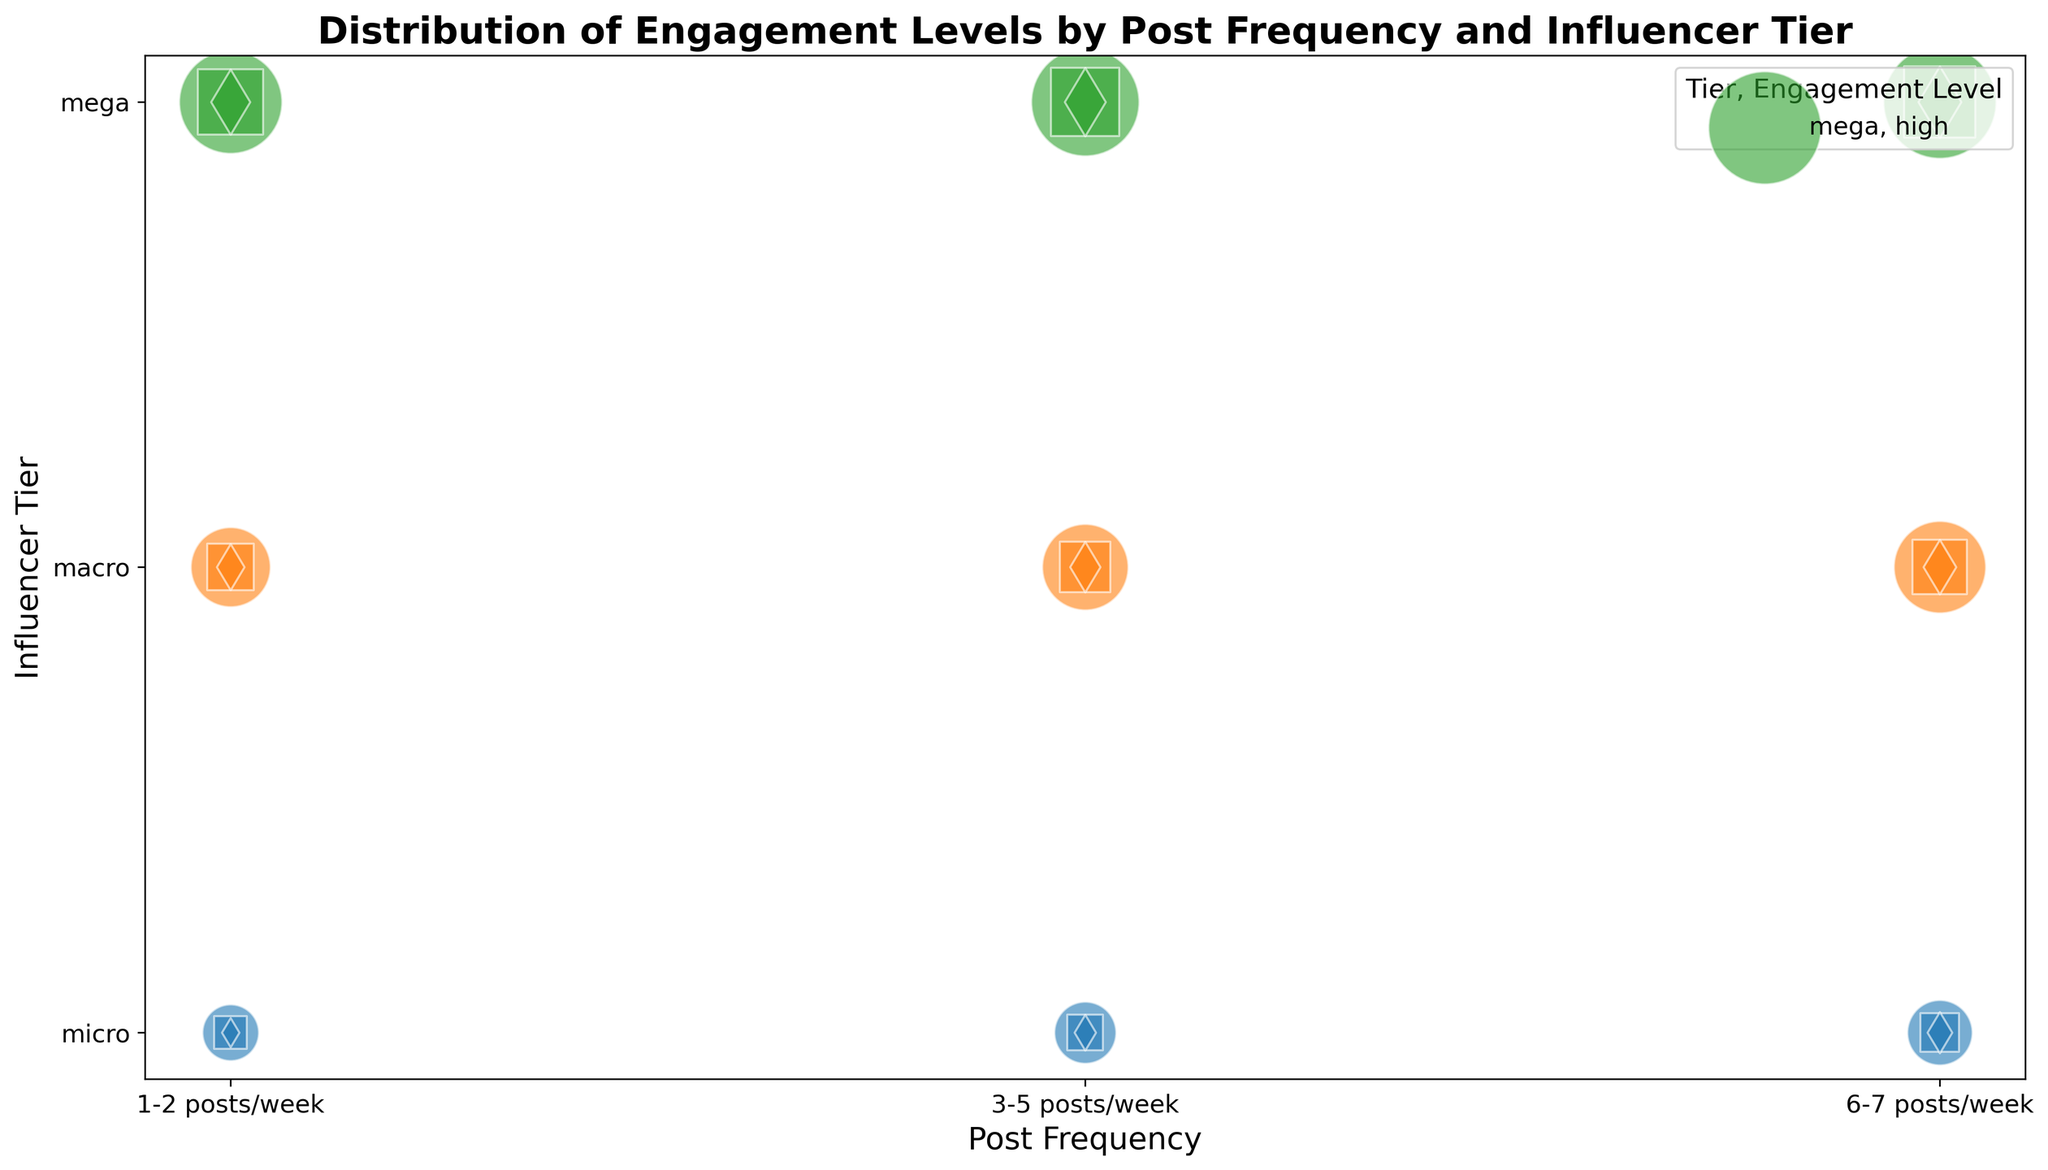What is the tier with the highest engagement count for 6-7 posts/week? For 6-7 posts/week, the bubble sizes represent engagement counts. The largest bubble size in this category appears in the "mega" tier for high engagement level.
Answer: mega Which engagement level is most common among micro influencers with 3-5 posts/week? The bubble sizes indicate the engagement counts for each level. The high engagement level has the largest bubble size among micro influencers with 3-5 posts/week.
Answer: high Compare the engagement counts for high engagement levels between macro influencers with 1-2 posts/week and micro influencers with the same frequency. Which tier has higher engagement? By comparing the bubble sizes for high engagement levels: macro influencers have a larger bubble size than micro influencers for 1-2 posts/week, indicating higher engagement.
Answer: macro What's the average engagement count for medium engagement levels across all tiers for 6-7 posts/week? Summing up the engagement counts for medium engagement levels at 6-7 posts/week: 70 (micro) + 140 (macro) + 240 (mega) = 450. There are 3 tiers, so the average is 450 / 3.
Answer: 150 How do the engagement counts for low engagement levels of mega influencers compare between 1-2 posts/week and 6-7 posts/week? Compare the bubble sizes for low engagement levels of mega influencers: 1-2 posts/week has an engagement count of 100, while 6-7 posts/week has 120, making the latter higher.
Answer: 6-7 posts/week Which post frequency leads to the highest engagement count for macro influencers? Look for the largest bubble size in the macro tier. The highest engagement count is found in the 6-7 posts/week category.
Answer: 6-7 posts/week Is there any post frequency where macro influencers have the same engagement count as mega influencers? Comparing bubbles, no single post frequency shows equal bubble sizes for macro and mega influencers in any engagement level.
Answer: No What is the combined engagement count for low engagement levels for micro influencers across all post frequencies? Sum the engagement counts for low engagement levels across all post frequencies for micro influencers: 20 (1-2 posts/week) + 30 (3-5 posts/week) + 40 (6-7 posts/week) = 90.
Answer: 90 In which tier and post frequency combination do we see the smallest bubble for high engagement levels? The smallest bubble for high engagement levels is visualized in the "micro" tier at 1-2 posts/week.
Answer: Micro, 1-2 posts/week 